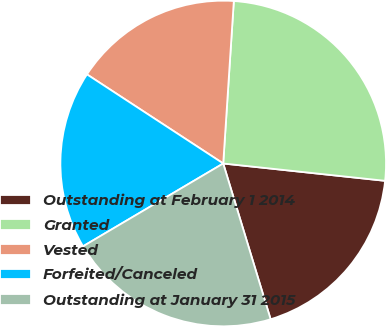<chart> <loc_0><loc_0><loc_500><loc_500><pie_chart><fcel>Outstanding at February 1 2014<fcel>Granted<fcel>Vested<fcel>Forfeited/Canceled<fcel>Outstanding at January 31 2015<nl><fcel>18.6%<fcel>25.66%<fcel>16.82%<fcel>17.71%<fcel>21.21%<nl></chart> 